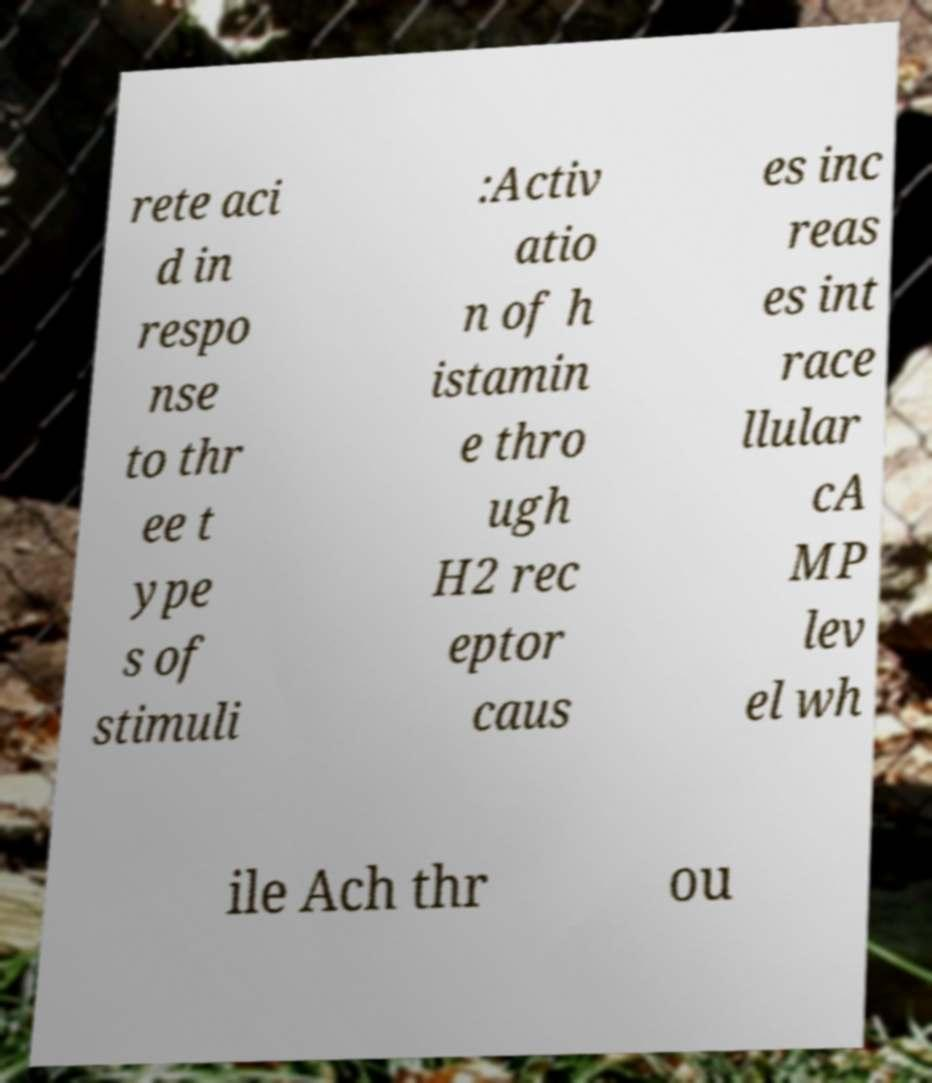Please read and relay the text visible in this image. What does it say? rete aci d in respo nse to thr ee t ype s of stimuli :Activ atio n of h istamin e thro ugh H2 rec eptor caus es inc reas es int race llular cA MP lev el wh ile Ach thr ou 